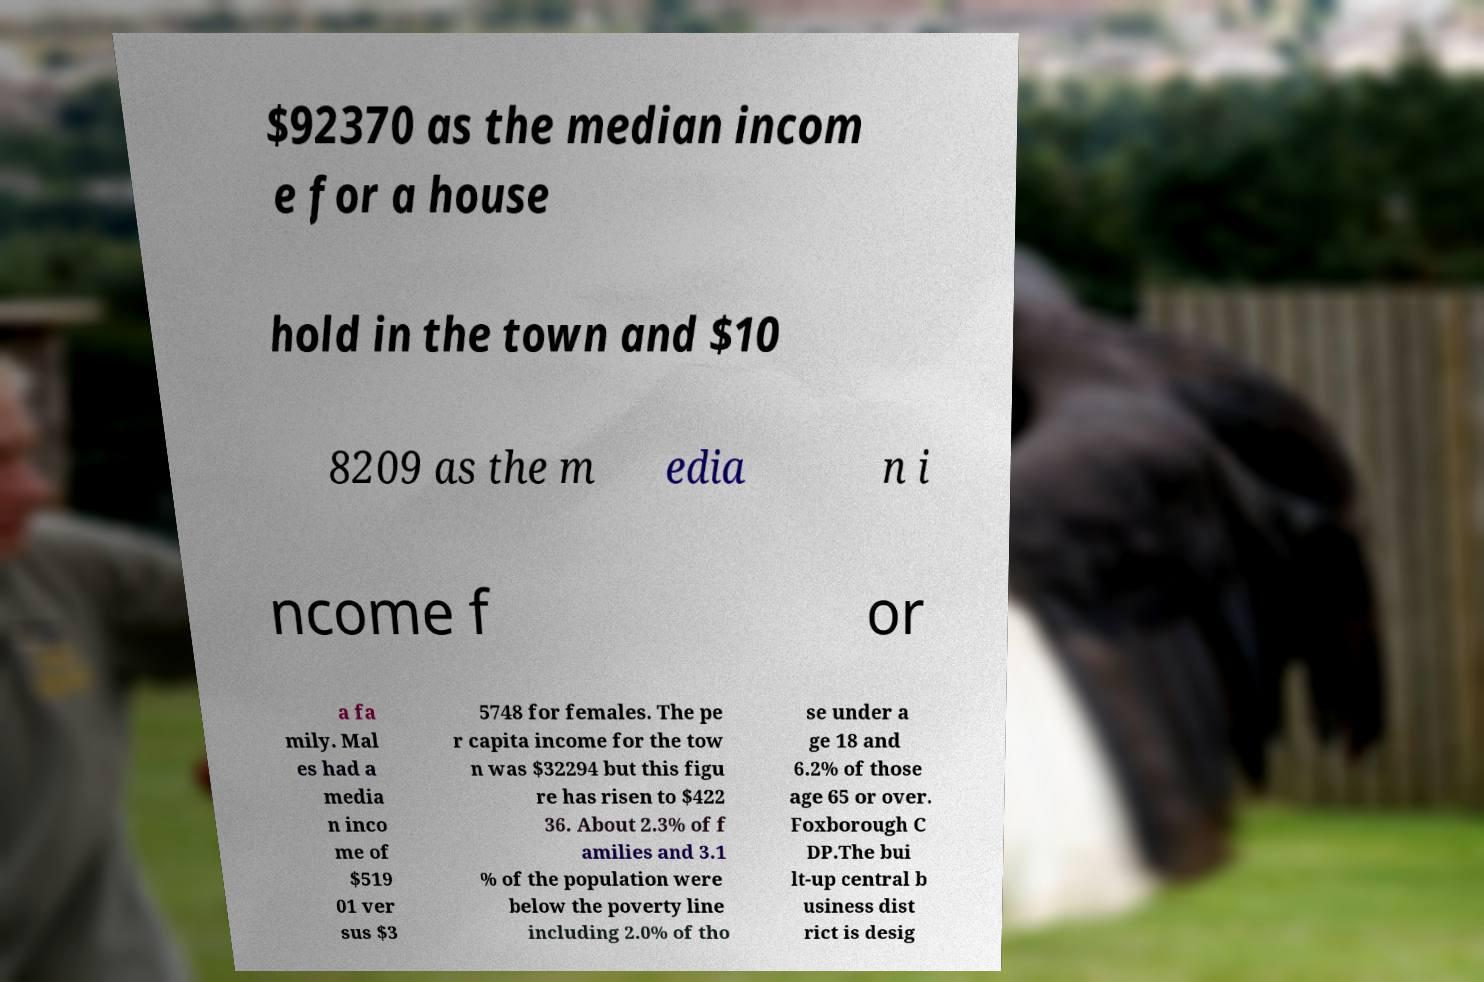Can you accurately transcribe the text from the provided image for me? $92370 as the median incom e for a house hold in the town and $10 8209 as the m edia n i ncome f or a fa mily. Mal es had a media n inco me of $519 01 ver sus $3 5748 for females. The pe r capita income for the tow n was $32294 but this figu re has risen to $422 36. About 2.3% of f amilies and 3.1 % of the population were below the poverty line including 2.0% of tho se under a ge 18 and 6.2% of those age 65 or over. Foxborough C DP.The bui lt-up central b usiness dist rict is desig 